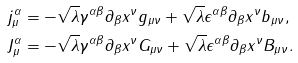Convert formula to latex. <formula><loc_0><loc_0><loc_500><loc_500>j _ { \mu } ^ { \alpha } & = - \sqrt { \lambda } \gamma ^ { \alpha \beta } \partial _ { \beta } x ^ { \nu } g _ { \mu \nu } + \sqrt { \lambda } \epsilon ^ { \alpha \beta } \partial _ { \beta } x ^ { \nu } b _ { \mu \nu } , \\ J _ { \mu } ^ { \alpha } & = - \sqrt { \lambda } \gamma ^ { \alpha \beta } \partial _ { \beta } x ^ { \nu } G _ { \mu \nu } + \sqrt { \lambda } \epsilon ^ { \alpha \beta } \partial _ { \beta } x ^ { \nu } B _ { \mu \nu } .</formula> 